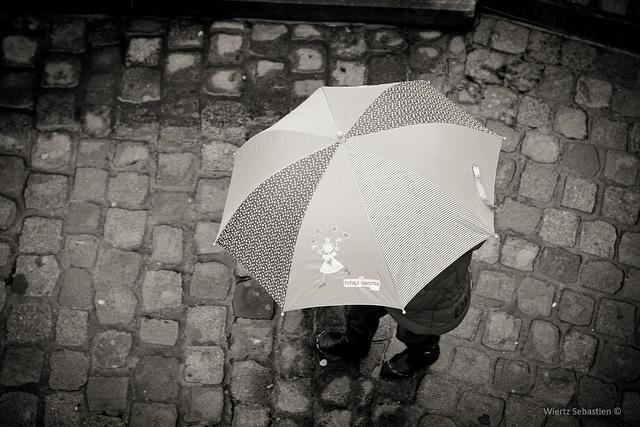How many people are visible?
Give a very brief answer. 2. 